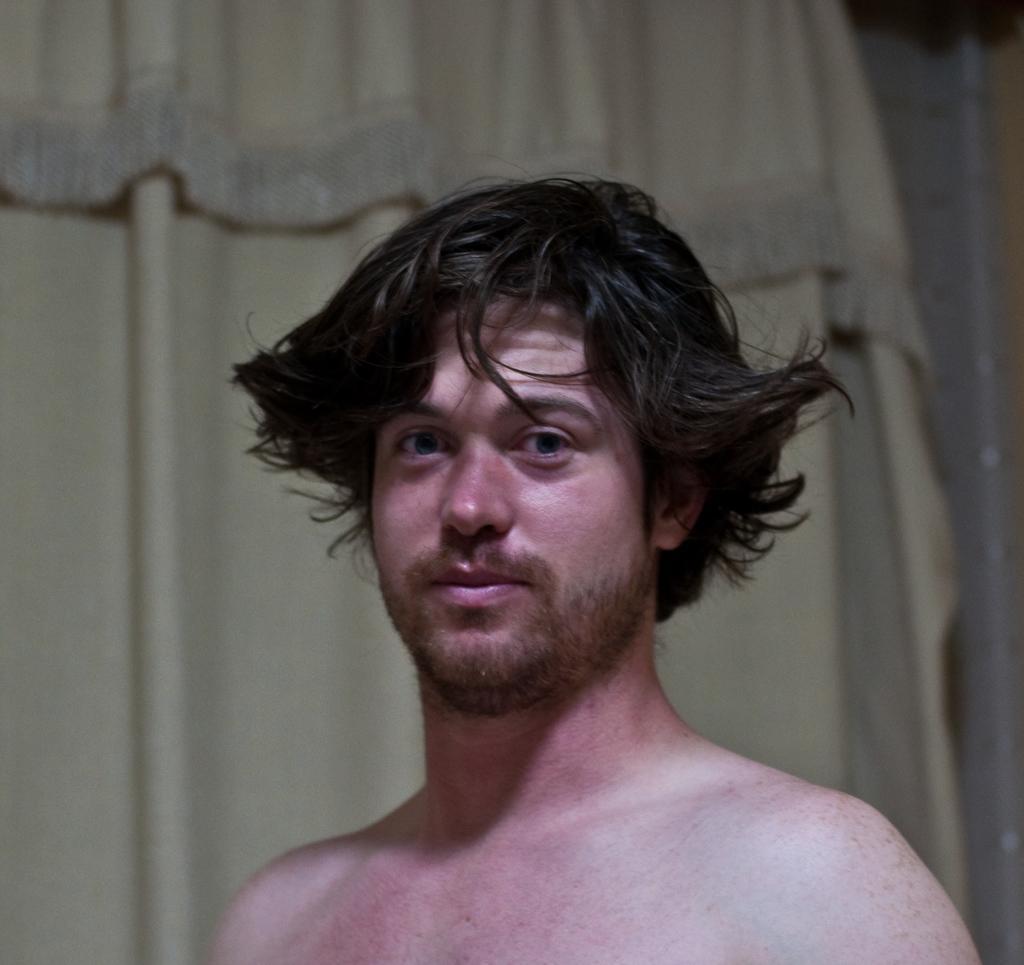In one or two sentences, can you explain what this image depicts? In this image we can see a person, behind him we can see the curtain. 